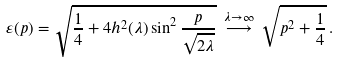<formula> <loc_0><loc_0><loc_500><loc_500>\varepsilon ( p ) = \sqrt { \frac { 1 } { 4 } + 4 h ^ { 2 } ( \lambda ) \sin ^ { 2 } \frac { p } { \sqrt { 2 \lambda } } } \, \stackrel { \lambda \rightarrow \infty } { \longrightarrow } \, \sqrt { p ^ { 2 } + \frac { 1 } { 4 } } \, .</formula> 